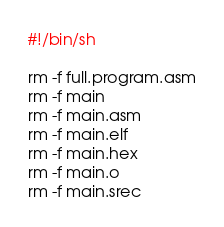<code> <loc_0><loc_0><loc_500><loc_500><_Bash_>#!/bin/sh

rm -f full.program.asm
rm -f main
rm -f main.asm
rm -f main.elf
rm -f main.hex
rm -f main.o
rm -f main.srec
</code> 